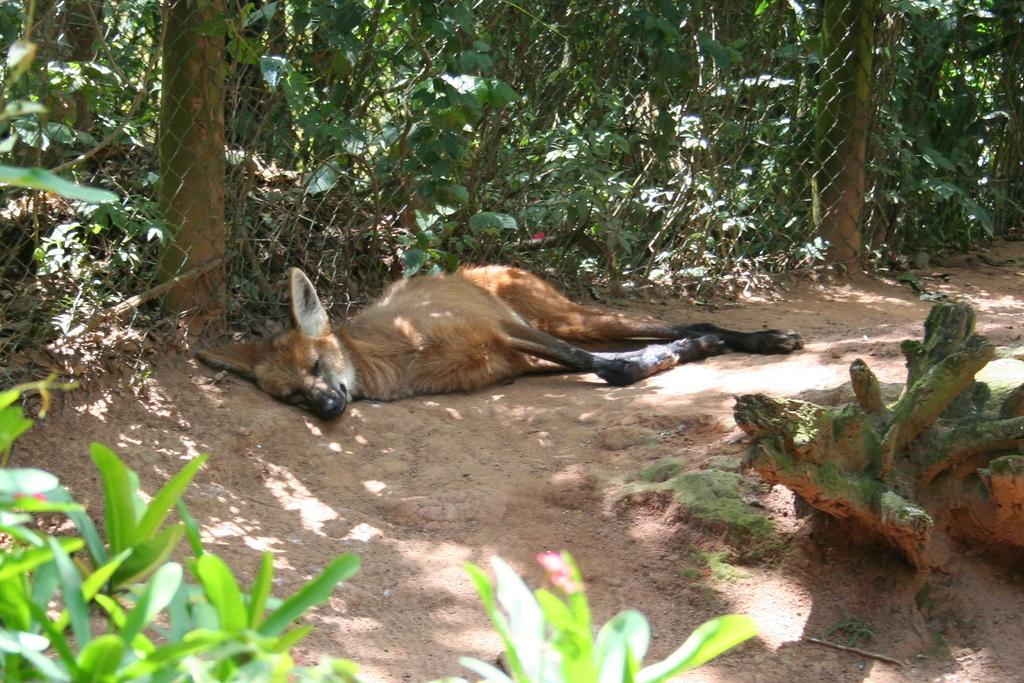What animal is present in the image? There is a fox in the image. What is the fox doing in the image? The fox is sleeping. What can be seen in the image that might serve as a barrier or boundary? There is a fence in the image. What type of natural environment is visible in the background of the image? There are trees visible in the background of the image. What month is it in the image? The month cannot be determined from the image, as it does not contain any information about the time of year. What type of oil is being used by the fox in the image? There is no oil present in the image, nor is there any indication that the fox is using any oil. 